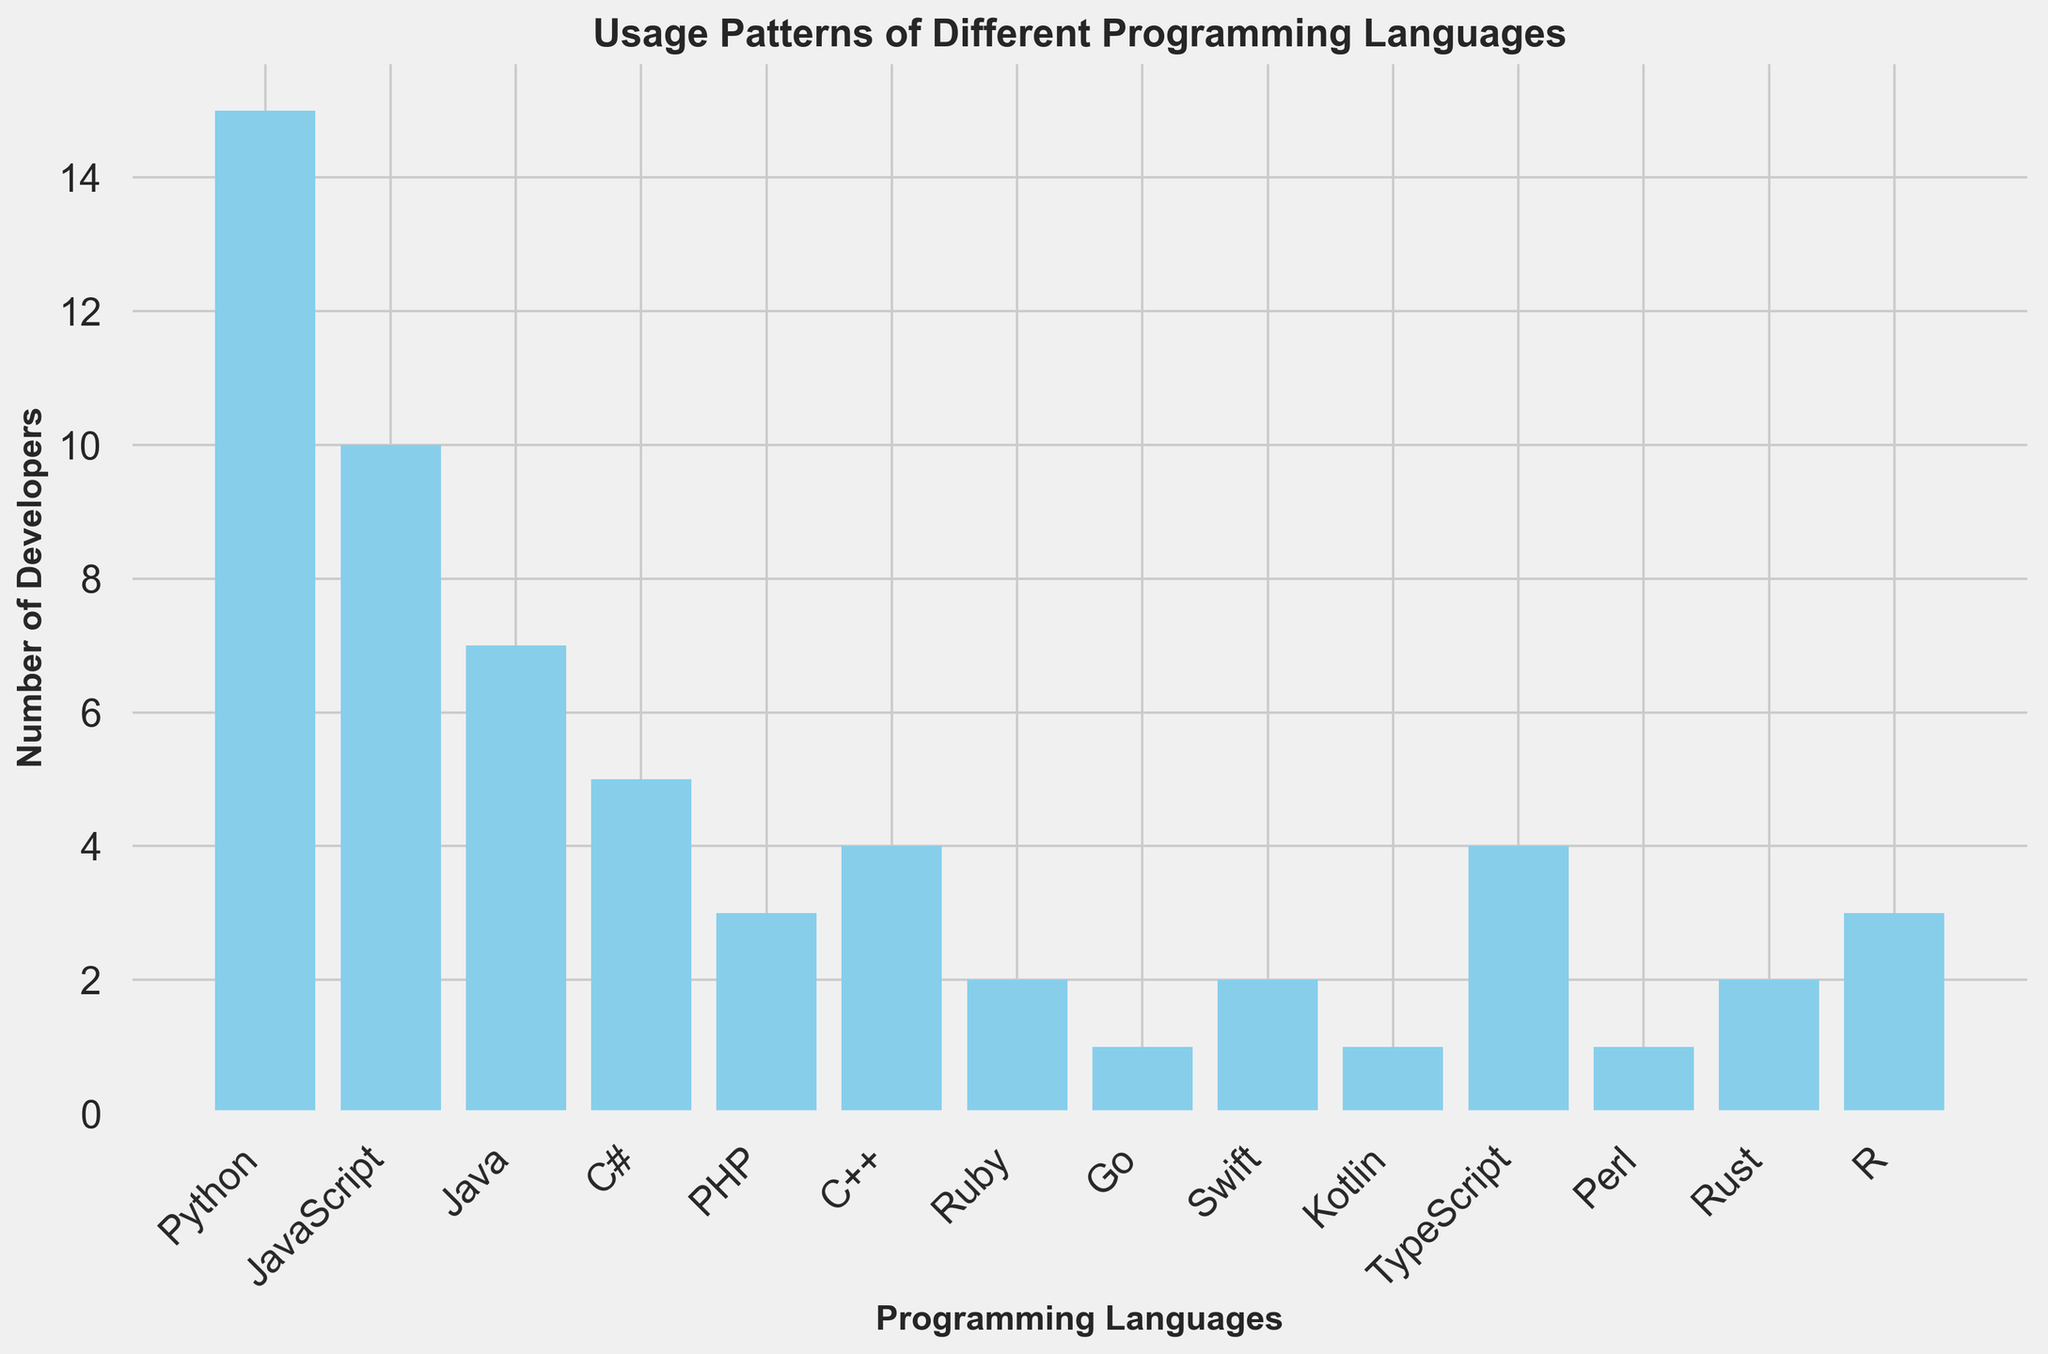what's the most popular programming language in the developer team? The figure shows the number of developers using each programming language. The tallest bar represents the language used by the most developers. In this case, Python has the tallest bar.
Answer: Python which programming language has exactly half the number of developers as JavaScript? JavaScript is used by 10 developers according to the figure. The language with half that number would have 5 developers. The figure shows that C# has 5 developers.
Answer: C# how many more developers use Python compared to PHP? The figure shows 15 developers use Python and 3 use PHP. The difference is calculated by subtracting the number of PHP developers from the number of Python developers: 15 - 3 = 12.
Answer: 12 which two programming languages have the same number of developers? By observing the heights of the bars, it is clear that TypeScript and C++ both have bars of the same height, each representing 4 developers.
Answer: TypeScript and C++ what is the total number of developers who use either Go, Kotlin, or Perl? The figure shows that Go, Kotlin, and Perl each have 1 developer. Summing these numbers: 1 + 1 + 1 = 3.
Answer: 3 which programming language has more developers, Rust or Ruby? The figure shows that Rust and Ruby each have bars but different heights. Rust has 2 developers and Ruby has the same number of developers: 2. Therefore, they are equal in the number of developers.
Answer: equal what's the ratio of developers using JavaScript to those using Java? The figure shows that JavaScript is used by 10 developers, and Java is used by 7 developers. The ratio is calculated as 10:7, which can also be written as 10/7.
Answer: 10:7 which programming language has the second highest number of developers? The figure shows the tallest bar (most developers) is for Python. The second tallest bar is for JavaScript. Hence, the second highest number of developers is for JavaScript.
Answer: JavaScript what's the average number of developers per programming language? There are 14 programming languages listed in the figure. Summing the total number of developers: 15 (Python) + 10 (JavaScript) + 7 (Java) + 5 (C#) + 3 (PHP) + 4 (C++) + 2 (Ruby) + 1 (Go) + 2 (Swift) + 1 (Kotlin) + 4 (TypeScript) + 1 (Perl) + 2 (Rust) + 3 (R) = 60. The average is calculated by dividing the total number by the number of programming languages: 60/14 ≈ 4.29.
Answer: 4.29 